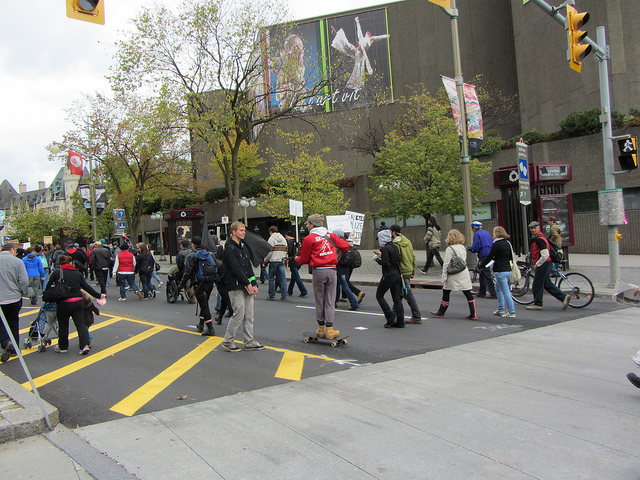<image>What is sticking out of the plastic bag? I don't know what is sticking out of the plastic bag. It can be groceries, items or newspaper. What sports team does the red t shirt depict? I am not sure what sports team the red t-shirt depicts. It might be 'cardinals', 'chicago bulls', 'chiefs', 'hockey team' or 'steelers'. What kind of animal? It's ambiguous what kind of animal is in the image. It could be a horse, dog, bird or even a human. What does the woman pushing the stroller have in her hand? It is ambiguous what the woman pushing the stroller has in her hand. It could be a bag or stroller handles. What is the man in the pink shirt riding? It is ambiguous whether the man in the pink shirt is riding anything. It can be a skateboard or he may not be in the image at all. What is sticking out of the plastic bag? I don't know what is sticking out of the plastic bag. It could be groceries, items, belongings, bread, newspaper or something else. What sports team does the red t shirt depict? I am not sure which sports team the red t-shirt depicts. It could be the Cardinals, Chicago Bulls, Chiefs, or Steelers. What kind of animal? I am not sure what kind of animal is in the image. It can be seen horse, human, dog or bird. What does the woman pushing the stroller have in her hand? I don't know what does the woman pushing the stroller have in her hand. It can be a bag, handles, a brown bag, coffee or none. What is the man in the pink shirt riding? I'm not sure what the man in the pink shirt is riding. It can be a skateboard or he might not be riding anything. 